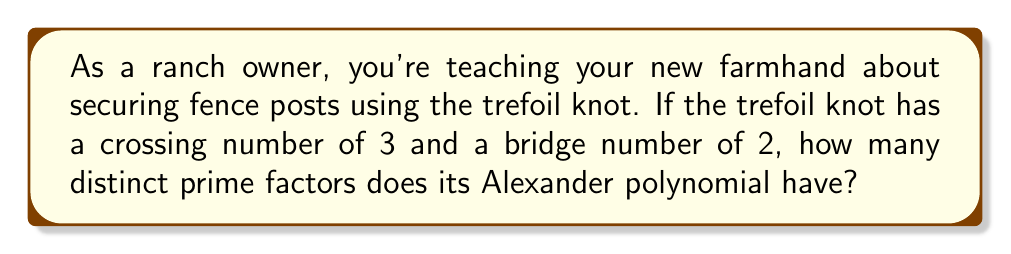Show me your answer to this math problem. Let's approach this step-by-step:

1) The Alexander polynomial of the trefoil knot is given by:

   $$\Delta(t) = t^2 - t + 1$$

2) To find the number of distinct prime factors, we need to factor this polynomial.

3) The polynomial $t^2 - t + 1$ is actually cyclotomic. It's the 3rd cyclotomic polynomial, denoted as $\Phi_3(t)$.

4) Cyclotomic polynomials are irreducible over the rational numbers. This means $t^2 - t + 1$ cannot be factored further over $\mathbb{Q}$.

5) Since it cannot be factored further, the entire polynomial $t^2 - t + 1$ is considered as one prime factor in this context.

6) Therefore, the Alexander polynomial of the trefoil knot has only one distinct prime factor.

This property of the trefoil knot's Alexander polynomial reflects its fundamental nature as one of the simplest non-trivial knots, which makes it useful for secure yet uncomplicated fence post ties on a ranch.
Answer: 1 